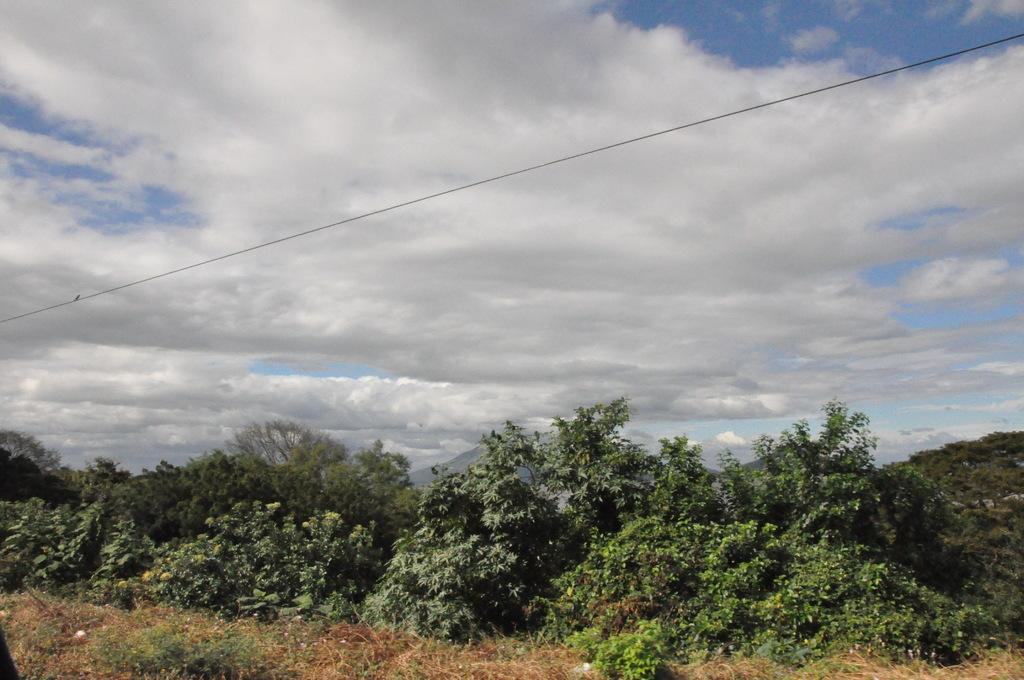What type of vegetation can be seen in the image? There are shrubs, bushes, and trees in the image. What type of landscape is depicted in the image? The image shows hills in the landscape. What is visible in the sky in the image? The sky is visible in the image, and clouds are present. What expert opinion is provided in the image? There is there any detail about the aftermath of a recent event? 